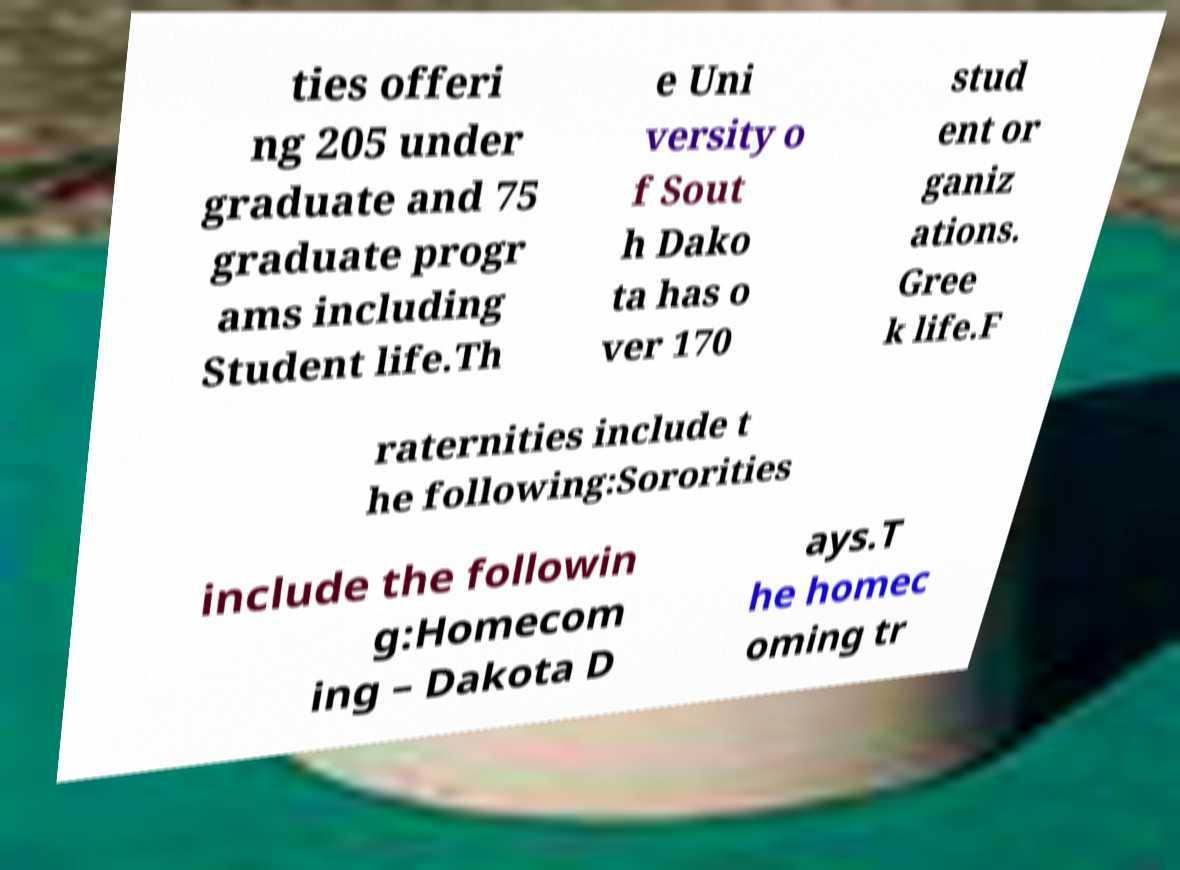There's text embedded in this image that I need extracted. Can you transcribe it verbatim? ties offeri ng 205 under graduate and 75 graduate progr ams including Student life.Th e Uni versity o f Sout h Dako ta has o ver 170 stud ent or ganiz ations. Gree k life.F raternities include t he following:Sororities include the followin g:Homecom ing – Dakota D ays.T he homec oming tr 